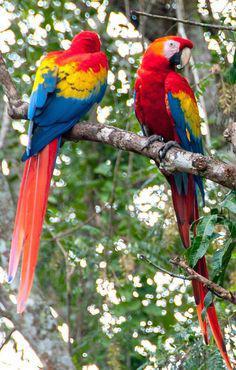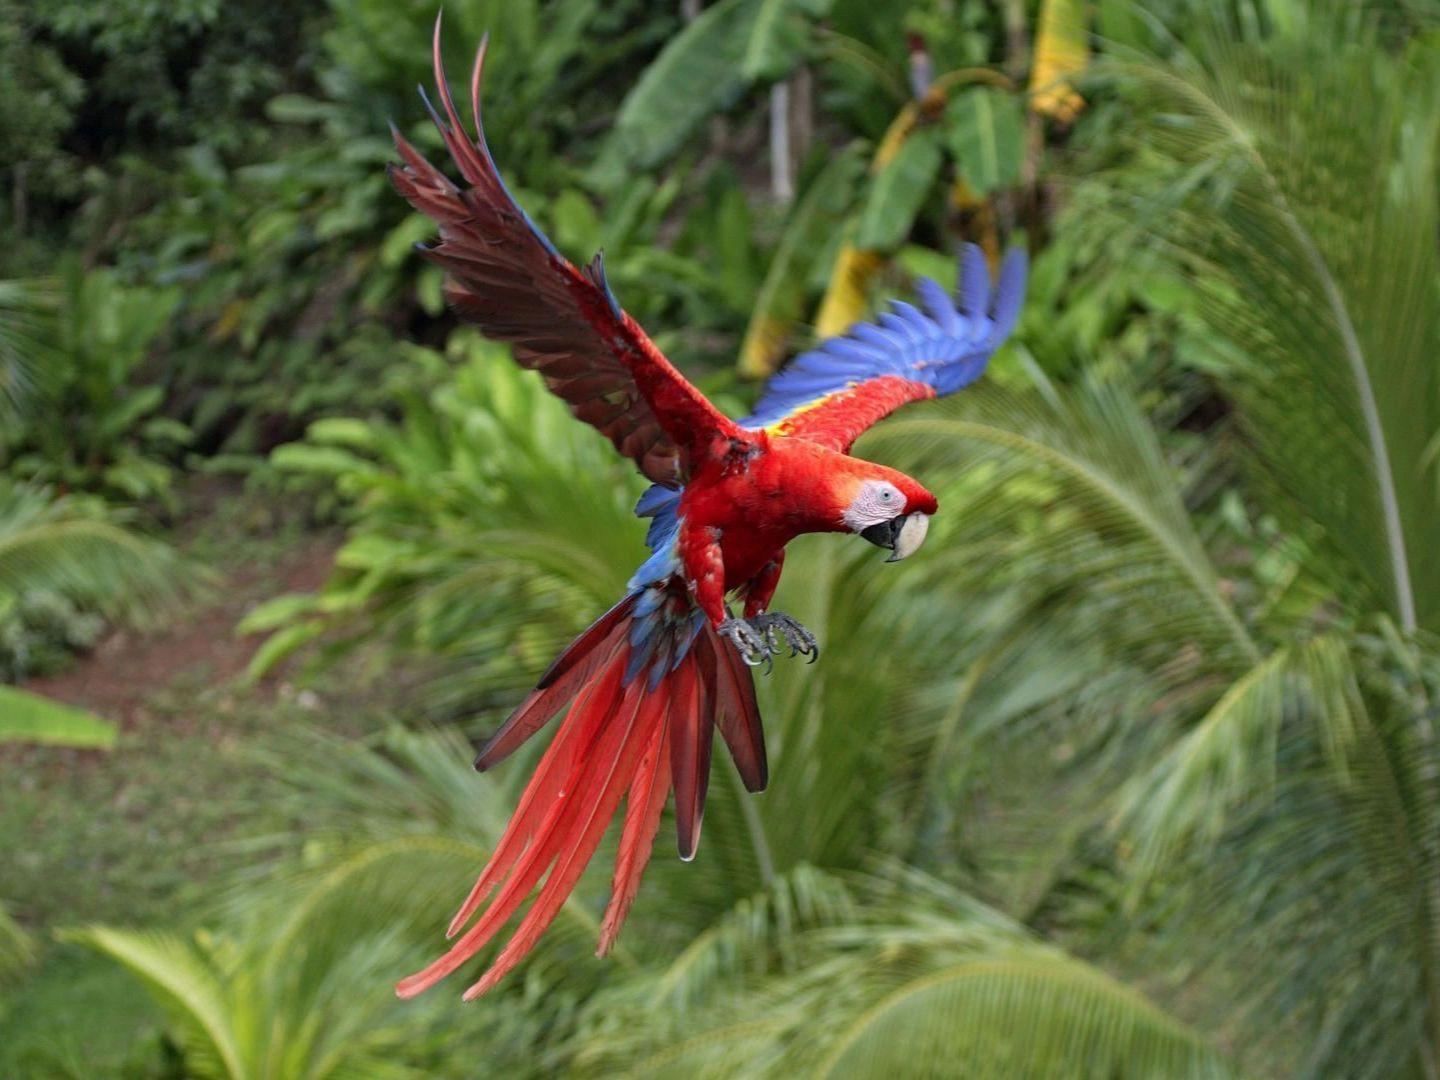The first image is the image on the left, the second image is the image on the right. For the images shown, is this caption "One of the birds in the right image has its wings spread." true? Answer yes or no. Yes. 